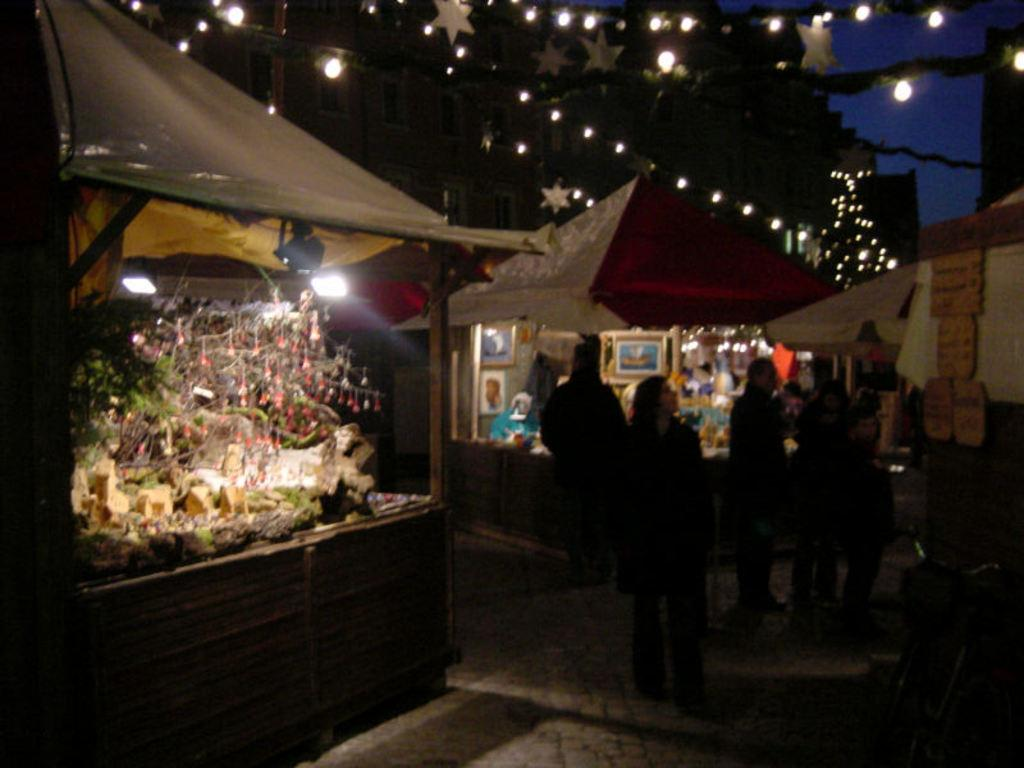What is located at the top of the image? There are lights at the top of the image. Where are the people in the image positioned? The people are standing on the right side of the image. What type of throne is present in the image? There is no throne present in the image. What direction are the people facing in the image? The provided facts do not specify the direction the people are facing, so we cannot definitively answer this question. 